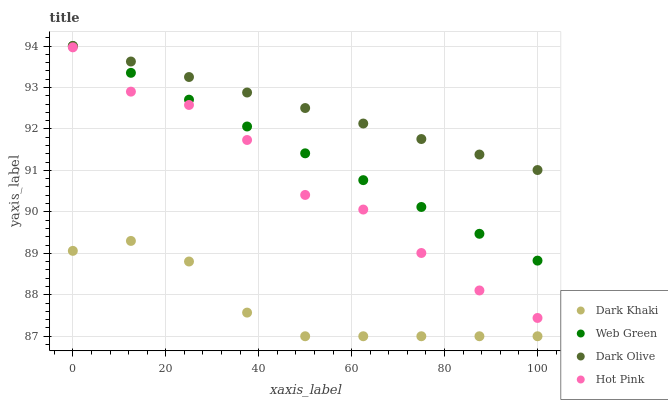Does Dark Khaki have the minimum area under the curve?
Answer yes or no. Yes. Does Dark Olive have the maximum area under the curve?
Answer yes or no. Yes. Does Web Green have the minimum area under the curve?
Answer yes or no. No. Does Web Green have the maximum area under the curve?
Answer yes or no. No. Is Dark Olive the smoothest?
Answer yes or no. Yes. Is Hot Pink the roughest?
Answer yes or no. Yes. Is Web Green the smoothest?
Answer yes or no. No. Is Web Green the roughest?
Answer yes or no. No. Does Dark Khaki have the lowest value?
Answer yes or no. Yes. Does Web Green have the lowest value?
Answer yes or no. No. Does Web Green have the highest value?
Answer yes or no. Yes. Does Hot Pink have the highest value?
Answer yes or no. No. Is Dark Khaki less than Web Green?
Answer yes or no. Yes. Is Web Green greater than Hot Pink?
Answer yes or no. Yes. Does Web Green intersect Dark Olive?
Answer yes or no. Yes. Is Web Green less than Dark Olive?
Answer yes or no. No. Is Web Green greater than Dark Olive?
Answer yes or no. No. Does Dark Khaki intersect Web Green?
Answer yes or no. No. 